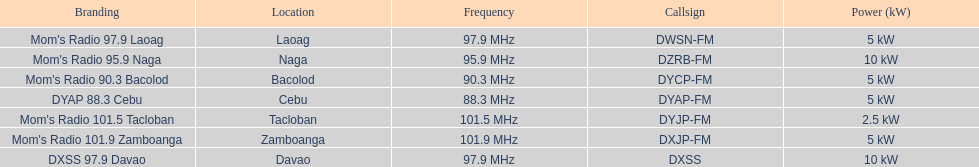What is the radio with the smallest mhz quantity? DYAP 88.3 Cebu. 